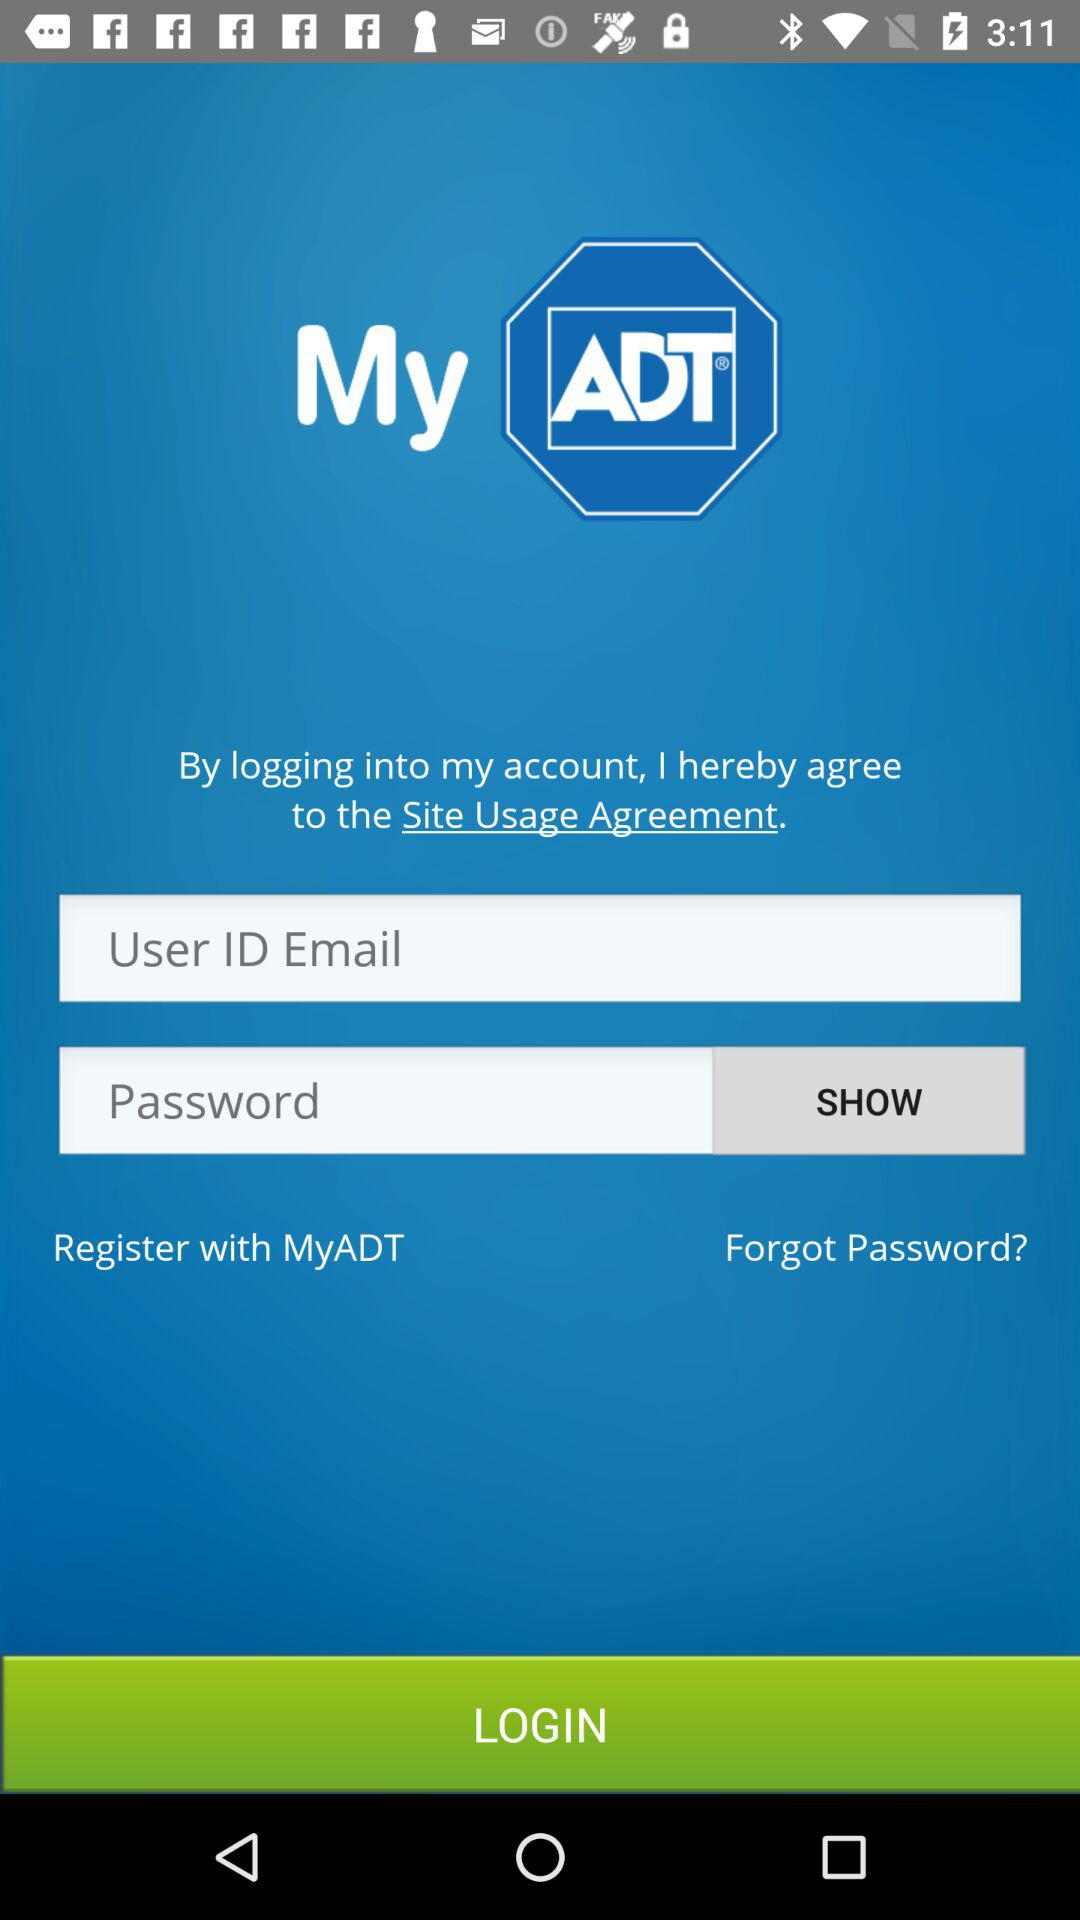What is the name of the application? The name of the application is "MyADT". 